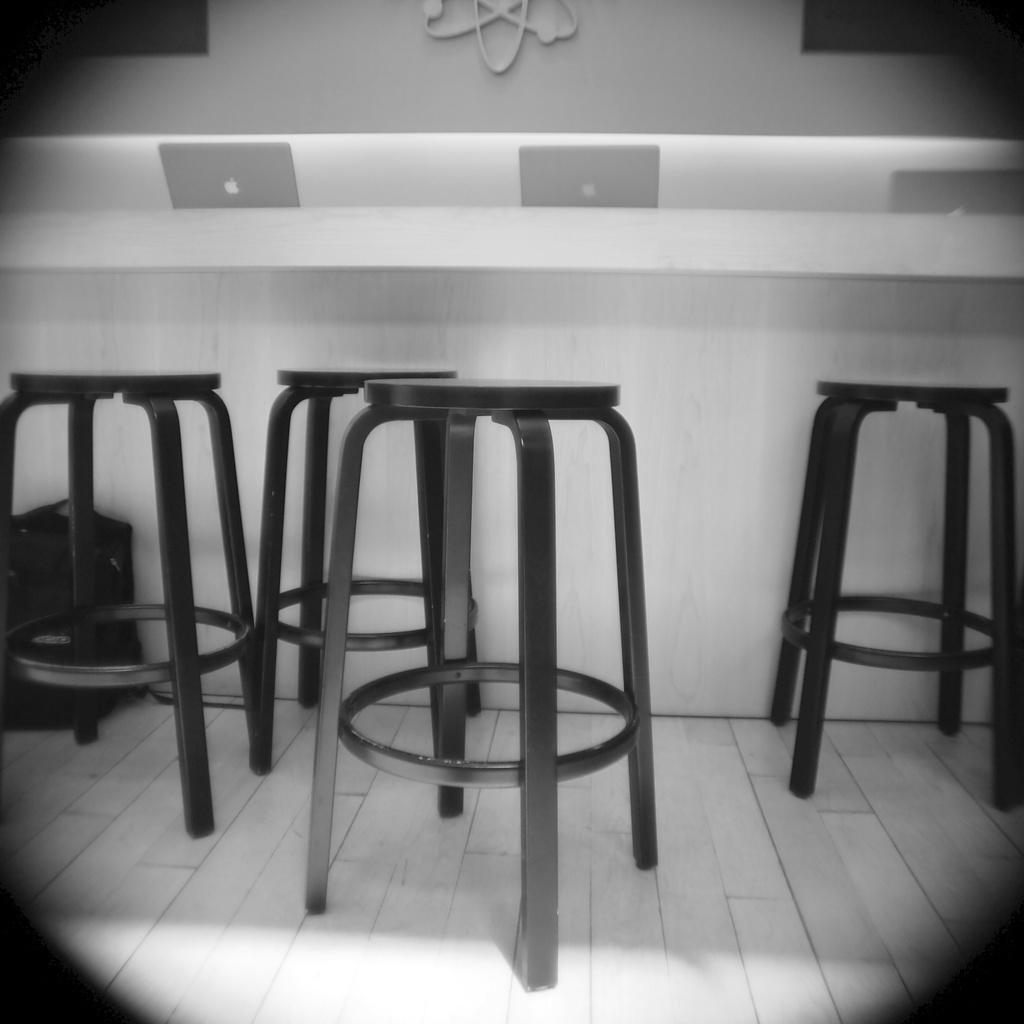What is the color scheme of the image? The image is black and white. What objects can be seen in the foreground of the image? There are stools in the foreground of the image. What electronic devices are present in the image? There are laptops on a desk in the image. What can be seen on the wall in the background of the image? The background of the image includes a white painted wall. How many keys are hanging on the worm in the image? There are no keys or worms present in the image. 